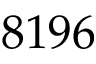Convert formula to latex. <formula><loc_0><loc_0><loc_500><loc_500>8 1 9 6</formula> 